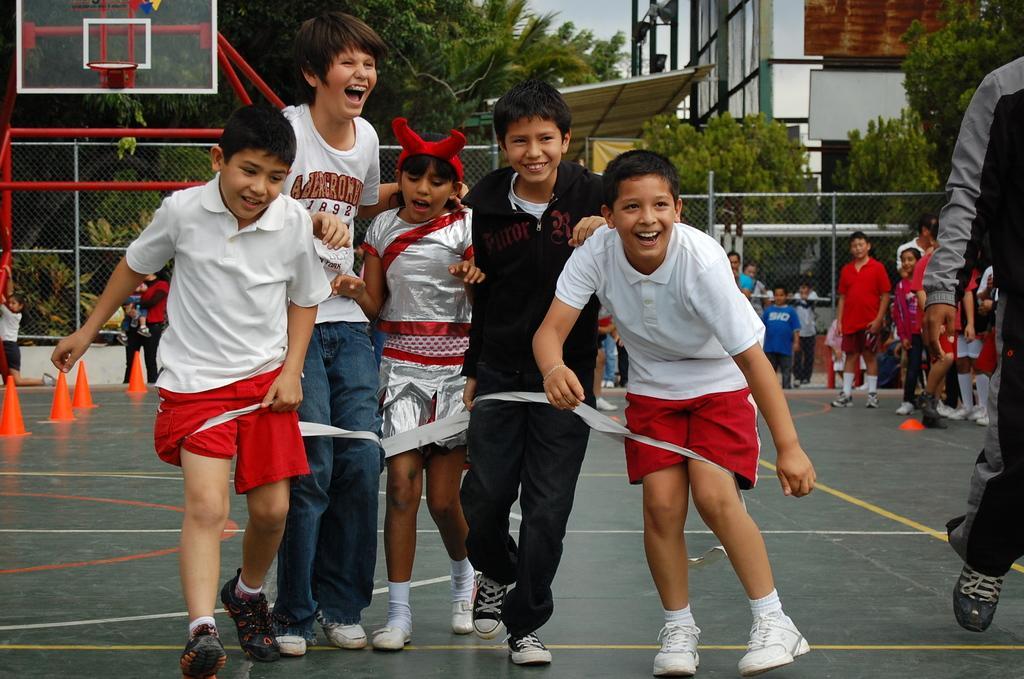In one or two sentences, can you explain what this image depicts? In this image there are group of people standing in basket ball coat are smiling, behind them there are so many other people standing and also there are trees and buildings. 